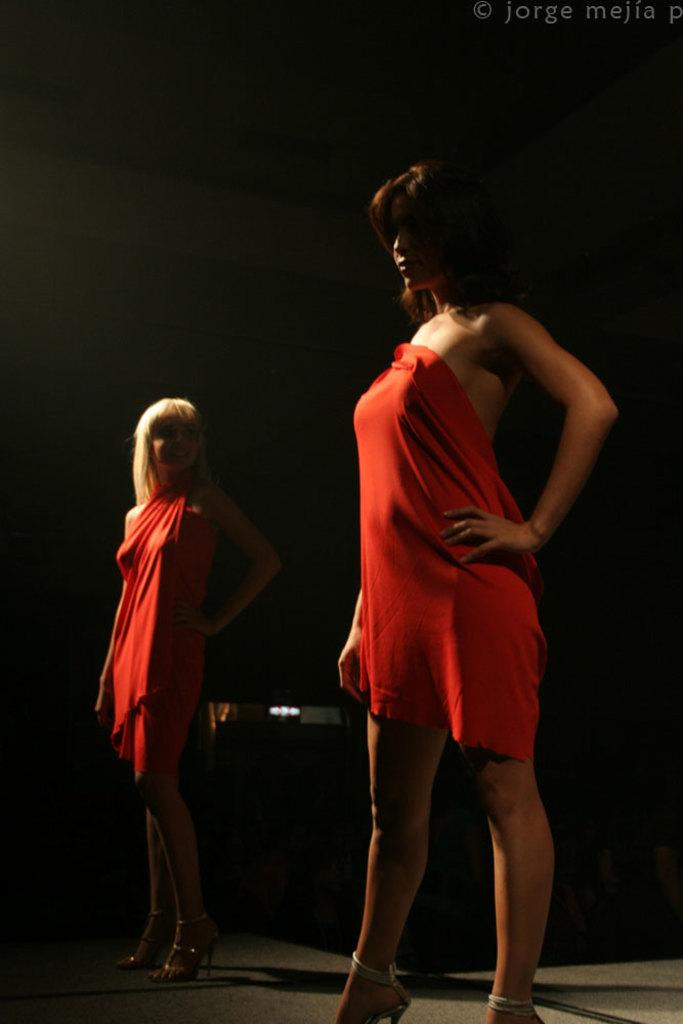How many people are in the image? There are two ladies in the image. What are the ladies wearing? Both ladies are wearing red dresses. What are the ladies doing in the image? The ladies are standing. Is there any text visible in the image? Yes, there is text in the top right corner of the image. How many sheep can be seen in the image? There are no sheep present in the image. What type of knowledge is being shared between the ladies in the image? The image does not provide any information about the ladies sharing knowledge or discussing any specific topic. 